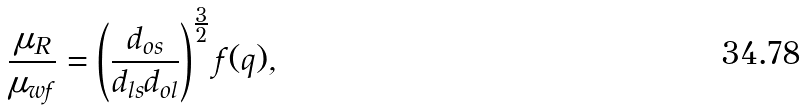<formula> <loc_0><loc_0><loc_500><loc_500>\frac { \mu _ { R } } { \mu _ { w f } } = \left ( \frac { d _ { o s } } { d _ { l s } d _ { o l } } \right ) ^ { \frac { 3 } { 2 } } f ( q ) ,</formula> 